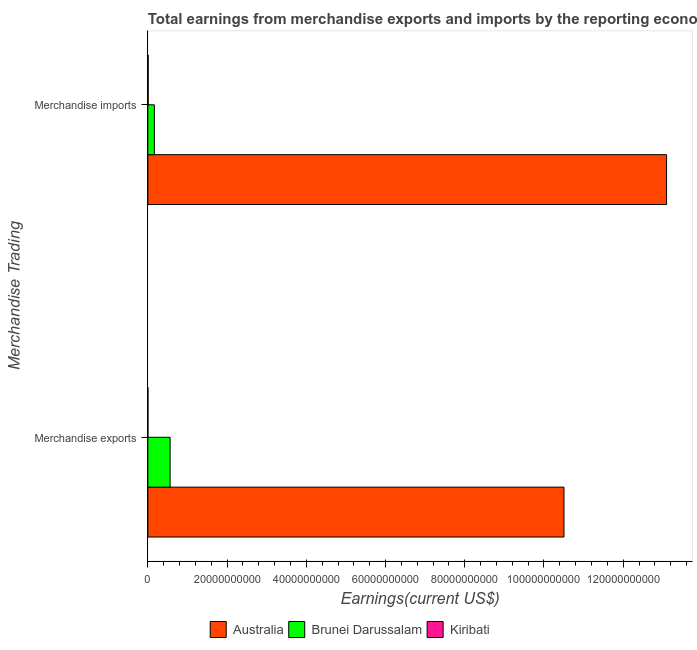Are the number of bars per tick equal to the number of legend labels?
Your answer should be compact. Yes. Are the number of bars on each tick of the Y-axis equal?
Offer a terse response. Yes. How many bars are there on the 1st tick from the top?
Keep it short and to the point. 3. What is the label of the 1st group of bars from the top?
Your answer should be compact. Merchandise imports. What is the earnings from merchandise exports in Brunei Darussalam?
Give a very brief answer. 5.62e+09. Across all countries, what is the maximum earnings from merchandise exports?
Give a very brief answer. 1.05e+11. Across all countries, what is the minimum earnings from merchandise exports?
Ensure brevity in your answer.  4.84e+06. In which country was the earnings from merchandise exports minimum?
Offer a terse response. Kiribati. What is the total earnings from merchandise imports in the graph?
Make the answer very short. 1.33e+11. What is the difference between the earnings from merchandise exports in Kiribati and that in Australia?
Provide a short and direct response. -1.05e+11. What is the difference between the earnings from merchandise imports in Brunei Darussalam and the earnings from merchandise exports in Australia?
Provide a short and direct response. -1.03e+11. What is the average earnings from merchandise imports per country?
Ensure brevity in your answer.  4.42e+1. What is the difference between the earnings from merchandise imports and earnings from merchandise exports in Kiribati?
Give a very brief answer. 7.29e+07. In how many countries, is the earnings from merchandise imports greater than 44000000000 US$?
Your answer should be compact. 1. What is the ratio of the earnings from merchandise exports in Brunei Darussalam to that in Australia?
Offer a terse response. 0.05. Is the earnings from merchandise imports in Australia less than that in Brunei Darussalam?
Provide a succinct answer. No. What does the 3rd bar from the bottom in Merchandise exports represents?
Your response must be concise. Kiribati. How many bars are there?
Make the answer very short. 6. How many countries are there in the graph?
Your answer should be compact. 3. What is the difference between two consecutive major ticks on the X-axis?
Offer a terse response. 2.00e+1. Does the graph contain any zero values?
Offer a very short reply. No. Does the graph contain grids?
Keep it short and to the point. No. Where does the legend appear in the graph?
Ensure brevity in your answer.  Bottom center. How are the legend labels stacked?
Keep it short and to the point. Horizontal. What is the title of the graph?
Your answer should be compact. Total earnings from merchandise exports and imports by the reporting economy in 2005. Does "France" appear as one of the legend labels in the graph?
Your answer should be compact. No. What is the label or title of the X-axis?
Give a very brief answer. Earnings(current US$). What is the label or title of the Y-axis?
Your answer should be compact. Merchandise Trading. What is the Earnings(current US$) in Australia in Merchandise exports?
Your response must be concise. 1.05e+11. What is the Earnings(current US$) in Brunei Darussalam in Merchandise exports?
Your answer should be compact. 5.62e+09. What is the Earnings(current US$) in Kiribati in Merchandise exports?
Make the answer very short. 4.84e+06. What is the Earnings(current US$) in Australia in Merchandise imports?
Make the answer very short. 1.31e+11. What is the Earnings(current US$) in Brunei Darussalam in Merchandise imports?
Give a very brief answer. 1.65e+09. What is the Earnings(current US$) in Kiribati in Merchandise imports?
Provide a succinct answer. 7.77e+07. Across all Merchandise Trading, what is the maximum Earnings(current US$) in Australia?
Provide a short and direct response. 1.31e+11. Across all Merchandise Trading, what is the maximum Earnings(current US$) of Brunei Darussalam?
Offer a very short reply. 5.62e+09. Across all Merchandise Trading, what is the maximum Earnings(current US$) of Kiribati?
Provide a succinct answer. 7.77e+07. Across all Merchandise Trading, what is the minimum Earnings(current US$) in Australia?
Give a very brief answer. 1.05e+11. Across all Merchandise Trading, what is the minimum Earnings(current US$) of Brunei Darussalam?
Your response must be concise. 1.65e+09. Across all Merchandise Trading, what is the minimum Earnings(current US$) in Kiribati?
Ensure brevity in your answer.  4.84e+06. What is the total Earnings(current US$) of Australia in the graph?
Provide a short and direct response. 2.36e+11. What is the total Earnings(current US$) in Brunei Darussalam in the graph?
Offer a terse response. 7.27e+09. What is the total Earnings(current US$) in Kiribati in the graph?
Your response must be concise. 8.25e+07. What is the difference between the Earnings(current US$) in Australia in Merchandise exports and that in Merchandise imports?
Keep it short and to the point. -2.59e+1. What is the difference between the Earnings(current US$) of Brunei Darussalam in Merchandise exports and that in Merchandise imports?
Keep it short and to the point. 3.97e+09. What is the difference between the Earnings(current US$) in Kiribati in Merchandise exports and that in Merchandise imports?
Your response must be concise. -7.29e+07. What is the difference between the Earnings(current US$) in Australia in Merchandise exports and the Earnings(current US$) in Brunei Darussalam in Merchandise imports?
Give a very brief answer. 1.03e+11. What is the difference between the Earnings(current US$) of Australia in Merchandise exports and the Earnings(current US$) of Kiribati in Merchandise imports?
Keep it short and to the point. 1.05e+11. What is the difference between the Earnings(current US$) in Brunei Darussalam in Merchandise exports and the Earnings(current US$) in Kiribati in Merchandise imports?
Ensure brevity in your answer.  5.54e+09. What is the average Earnings(current US$) of Australia per Merchandise Trading?
Offer a very short reply. 1.18e+11. What is the average Earnings(current US$) of Brunei Darussalam per Merchandise Trading?
Offer a very short reply. 3.63e+09. What is the average Earnings(current US$) in Kiribati per Merchandise Trading?
Ensure brevity in your answer.  4.13e+07. What is the difference between the Earnings(current US$) in Australia and Earnings(current US$) in Brunei Darussalam in Merchandise exports?
Your answer should be very brief. 9.94e+1. What is the difference between the Earnings(current US$) in Australia and Earnings(current US$) in Kiribati in Merchandise exports?
Ensure brevity in your answer.  1.05e+11. What is the difference between the Earnings(current US$) of Brunei Darussalam and Earnings(current US$) of Kiribati in Merchandise exports?
Provide a short and direct response. 5.61e+09. What is the difference between the Earnings(current US$) of Australia and Earnings(current US$) of Brunei Darussalam in Merchandise imports?
Your answer should be compact. 1.29e+11. What is the difference between the Earnings(current US$) of Australia and Earnings(current US$) of Kiribati in Merchandise imports?
Ensure brevity in your answer.  1.31e+11. What is the difference between the Earnings(current US$) of Brunei Darussalam and Earnings(current US$) of Kiribati in Merchandise imports?
Provide a short and direct response. 1.57e+09. What is the ratio of the Earnings(current US$) in Australia in Merchandise exports to that in Merchandise imports?
Offer a very short reply. 0.8. What is the ratio of the Earnings(current US$) in Brunei Darussalam in Merchandise exports to that in Merchandise imports?
Make the answer very short. 3.41. What is the ratio of the Earnings(current US$) of Kiribati in Merchandise exports to that in Merchandise imports?
Your response must be concise. 0.06. What is the difference between the highest and the second highest Earnings(current US$) in Australia?
Provide a short and direct response. 2.59e+1. What is the difference between the highest and the second highest Earnings(current US$) of Brunei Darussalam?
Give a very brief answer. 3.97e+09. What is the difference between the highest and the second highest Earnings(current US$) of Kiribati?
Give a very brief answer. 7.29e+07. What is the difference between the highest and the lowest Earnings(current US$) in Australia?
Your answer should be very brief. 2.59e+1. What is the difference between the highest and the lowest Earnings(current US$) in Brunei Darussalam?
Ensure brevity in your answer.  3.97e+09. What is the difference between the highest and the lowest Earnings(current US$) of Kiribati?
Provide a succinct answer. 7.29e+07. 